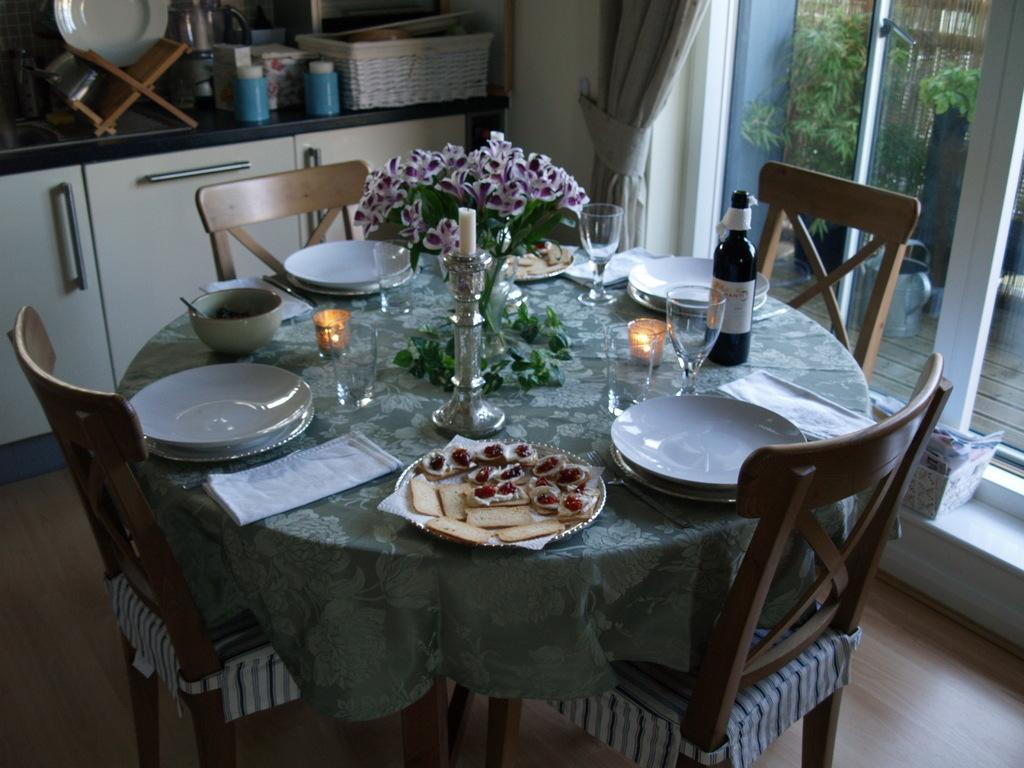Describe this image in one or two sentences. In this image we can see table with chairs. On the table there is a candle with stand, plates, bowl, glasses, vase with flowers, bottle, plate with food items, napkins, lights and few other things. On the right side there are doors. Near to the door there is a box. In the back there is a platform with cupboard. On that there is a book stand, plate, bottles, basket and some other items. Also there is a curtain. Through the door we can see plants. 